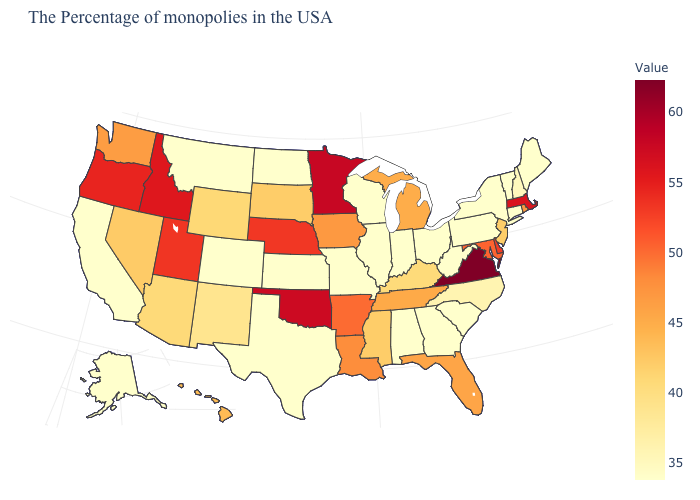Which states hav the highest value in the West?
Concise answer only. Idaho. Among the states that border Delaware , which have the highest value?
Short answer required. Maryland. Does Montana have the lowest value in the USA?
Short answer required. Yes. Which states hav the highest value in the West?
Concise answer only. Idaho. Does the map have missing data?
Be succinct. No. 